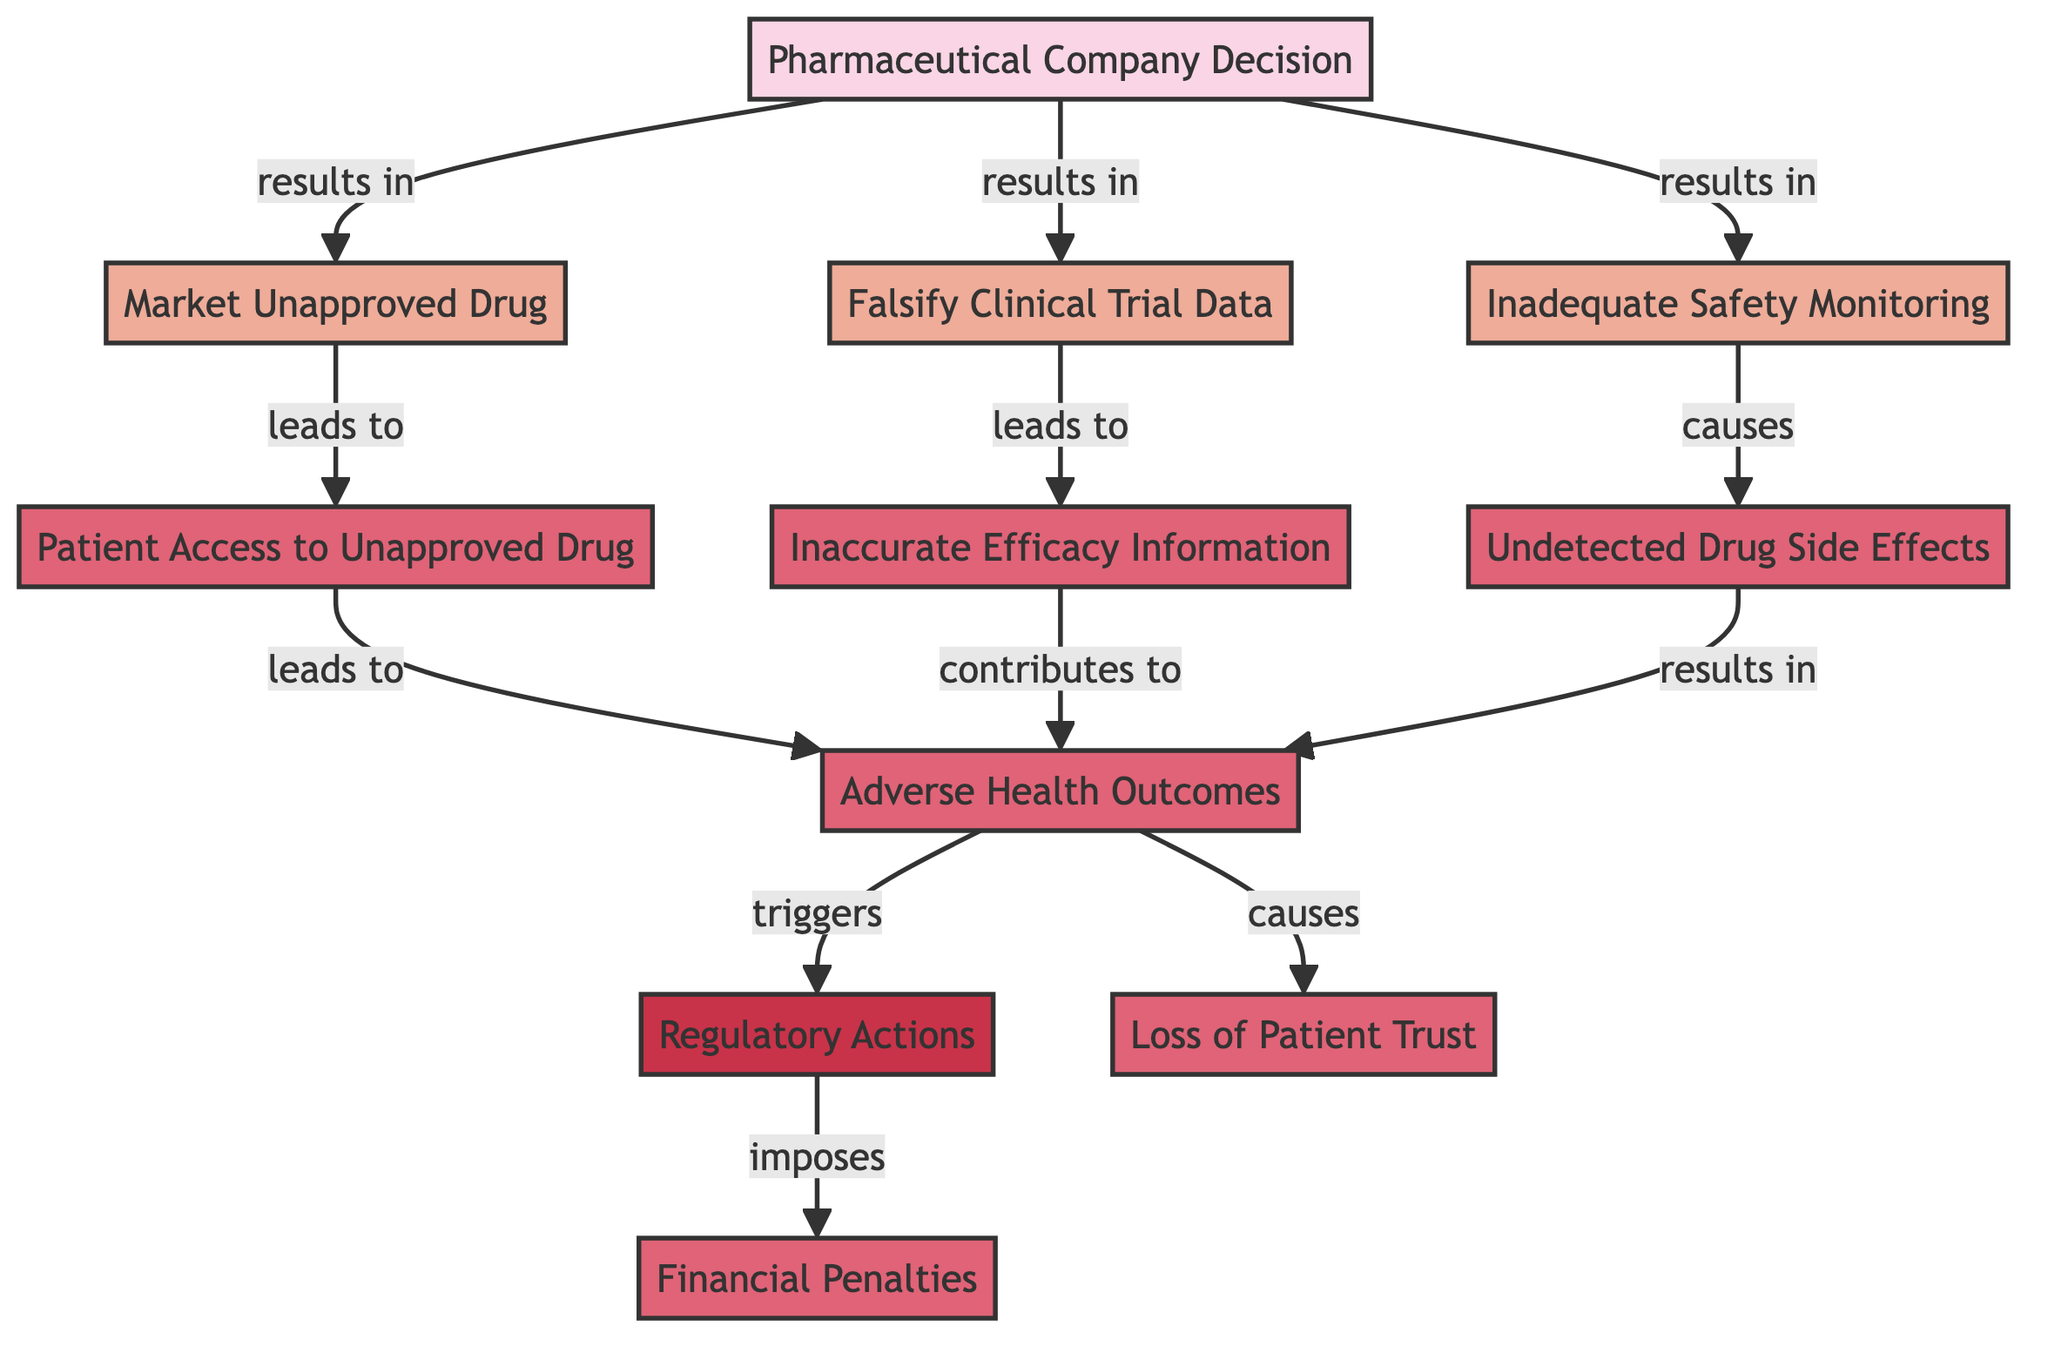What is the first decision made by the pharmaceutical company? The diagram indicates that the first decision made by the pharmaceutical company is to market an unapproved drug.
Answer: Market Unapproved Drug How many outcomes are listed in the diagram? By counting the outcome nodes in the diagram, we find there are five outcomes: patient access to unapproved drug, inaccurate efficacy information, undetected drug side effects, adverse health outcomes, and loss of patient trust.
Answer: Five What does inadequate safety monitoring cause? According to the flowchart, inadequate safety monitoring leads to undetected drug side effects.
Answer: Undetected Drug Side Effects What triggers regulatory actions? The diagram shows that adverse health outcomes trigger regulatory actions.
Answer: Adverse Health Outcomes What type of actions result from falsifying clinical trial data? The diagram states that falsifying clinical trial data leads to inaccurate efficacy information.
Answer: Inaccurate Efficacy Information What are the consequences of adverse health outcomes? The diagram connects adverse health outcomes to two consequences: regulatory actions and loss of patient trust. Thus, they are both outcomes resulting from adverse health outcomes.
Answer: Regulatory Actions and Loss of Patient Trust How many decisions does the pharmaceutical company make? The diagram indicates there is one main decision made by the pharmaceutical company which branches into multiple actions.
Answer: One What is the final consequence that follows regulatory actions? The flowchart shows that regulatory actions impose financial penalties as a consequence.
Answer: Financial Penalties Which action directly leads to patient access to an unapproved drug? The diagram reveals that marketing an unapproved drug directly leads to patient access to that drug.
Answer: Marketing Unapproved Drug 